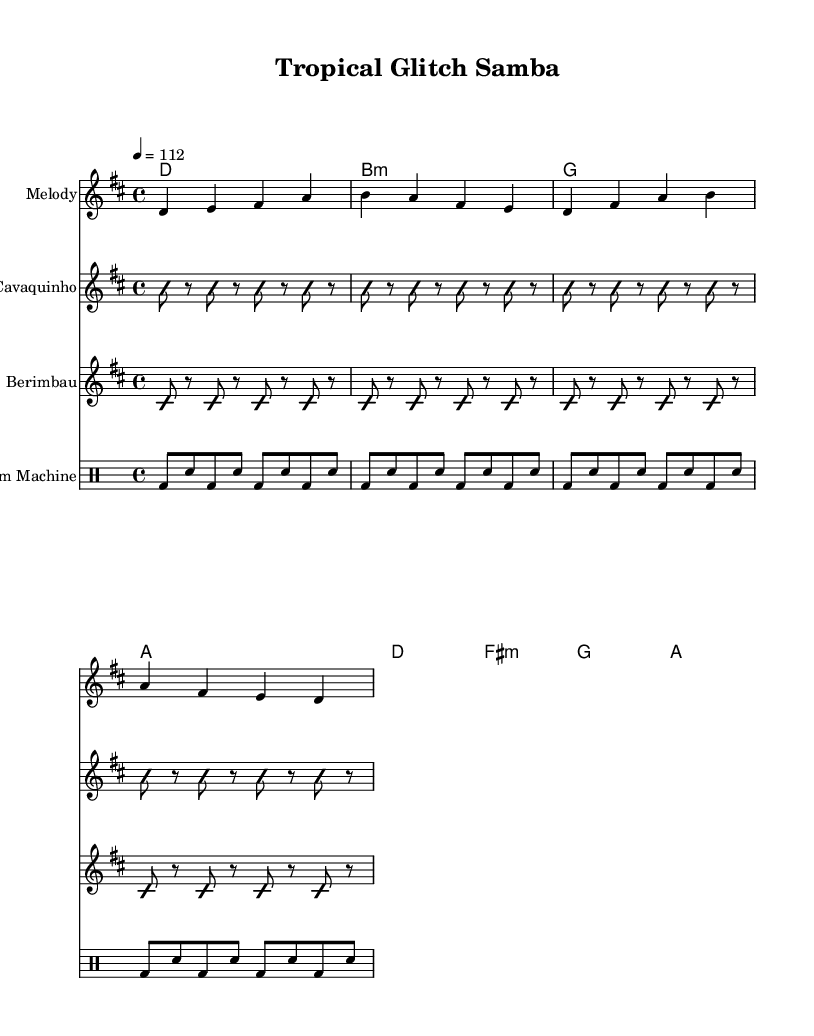What is the key signature of this music? The key signature is indicated at the beginning of the staff, showing two sharps which signify D major.
Answer: D major What is the time signature of this music? The time signature appears at the beginning of the score, displayed as a fraction with a top number of 4 and a bottom number of 4.
Answer: 4/4 What is the tempo marking in this music? The tempo marking indicates a speed of 112 beats per minute, visible under the initial header in the score.
Answer: 112 How many instruments are featured in this score? Counting the distinct staves, there are four different instruments represented: Melody, Cavaquinho, Berimbau, and Drum Machine.
Answer: Four What is the rhythmic pattern played by the Cavaquinho? The rhythmic pattern consists of a series of repeated 'b' notes interspersed with rests, revealed in the Cavaquinho staff.
Answer: Repeated 'b' notes with rests Which instrument plays the primary melodic theme? The melody is represented in the first staff labeled "Melody," which carries the main melodic theme.
Answer: Melody What genre influences can be identified in this music? The use of traditional Brazilian instruments like the Cavaquinho and Berimbau, combined with electronic drum patterns, indicates a fusion of Brazilian Tropicália and avant-garde electronica.
Answer: Brazilian Tropicália and avant-garde electronica 